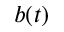Convert formula to latex. <formula><loc_0><loc_0><loc_500><loc_500>b ( t )</formula> 